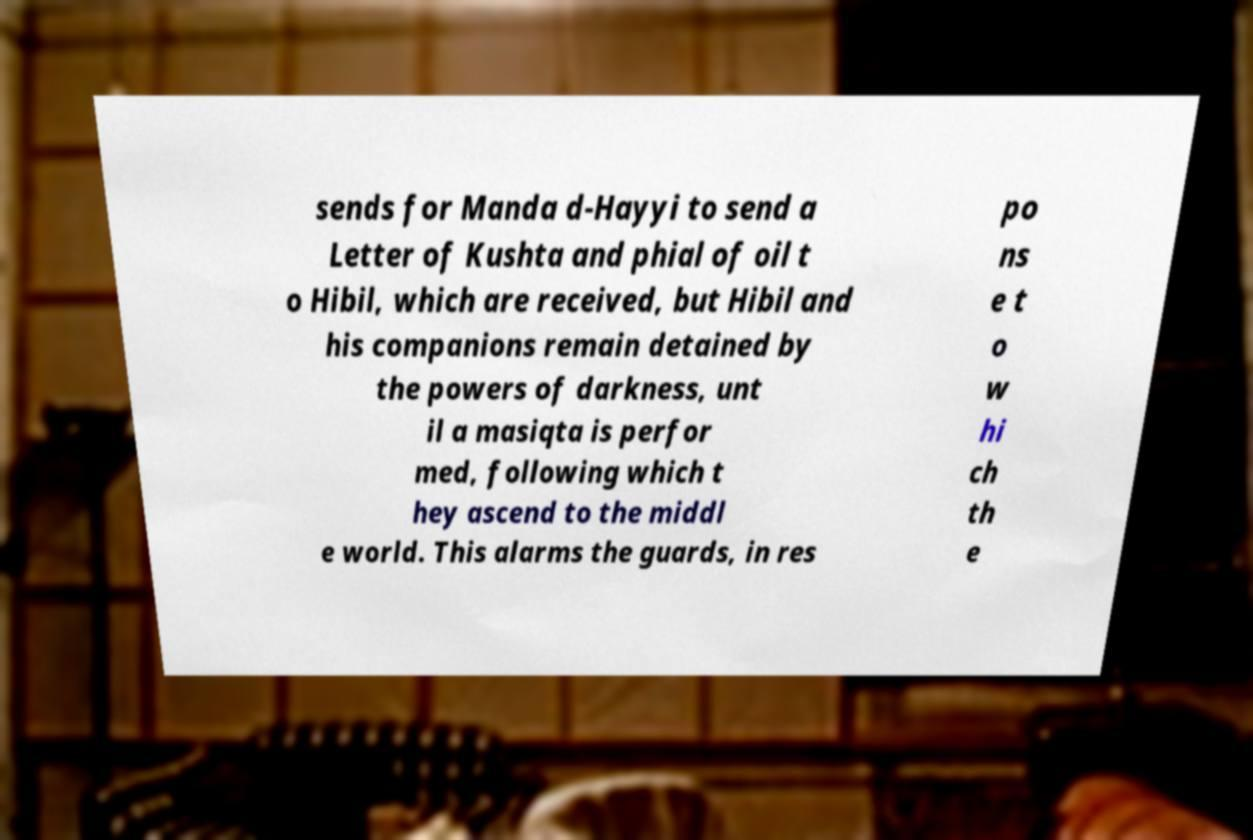Please read and relay the text visible in this image. What does it say? sends for Manda d-Hayyi to send a Letter of Kushta and phial of oil t o Hibil, which are received, but Hibil and his companions remain detained by the powers of darkness, unt il a masiqta is perfor med, following which t hey ascend to the middl e world. This alarms the guards, in res po ns e t o w hi ch th e 